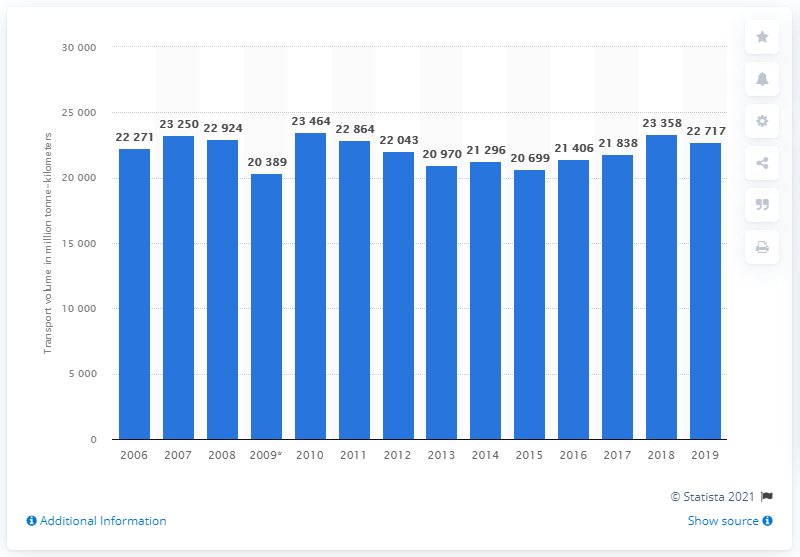Identify some key points in this picture. According to data from 2019, the rail freight transport volume in Sweden was 22,717. 